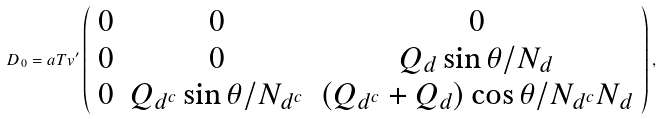Convert formula to latex. <formula><loc_0><loc_0><loc_500><loc_500>D _ { 0 } = a T v ^ { \prime } \left ( \begin{array} { c c c } 0 & 0 & 0 \\ 0 & 0 & Q _ { d } \sin \theta / N _ { d } \\ 0 & Q _ { d ^ { c } } \sin \theta / N _ { d ^ { c } } & ( Q _ { d ^ { c } } + Q _ { d } ) \cos \theta / N _ { d ^ { c } } N _ { d } \end{array} \right ) ,</formula> 